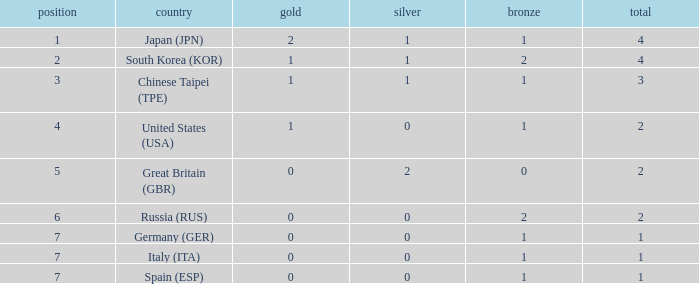How many total medals does a country with more than 1 silver medals have? 2.0. Would you be able to parse every entry in this table? {'header': ['position', 'country', 'gold', 'silver', 'bronze', 'total'], 'rows': [['1', 'Japan (JPN)', '2', '1', '1', '4'], ['2', 'South Korea (KOR)', '1', '1', '2', '4'], ['3', 'Chinese Taipei (TPE)', '1', '1', '1', '3'], ['4', 'United States (USA)', '1', '0', '1', '2'], ['5', 'Great Britain (GBR)', '0', '2', '0', '2'], ['6', 'Russia (RUS)', '0', '0', '2', '2'], ['7', 'Germany (GER)', '0', '0', '1', '1'], ['7', 'Italy (ITA)', '0', '0', '1', '1'], ['7', 'Spain (ESP)', '0', '0', '1', '1']]} 